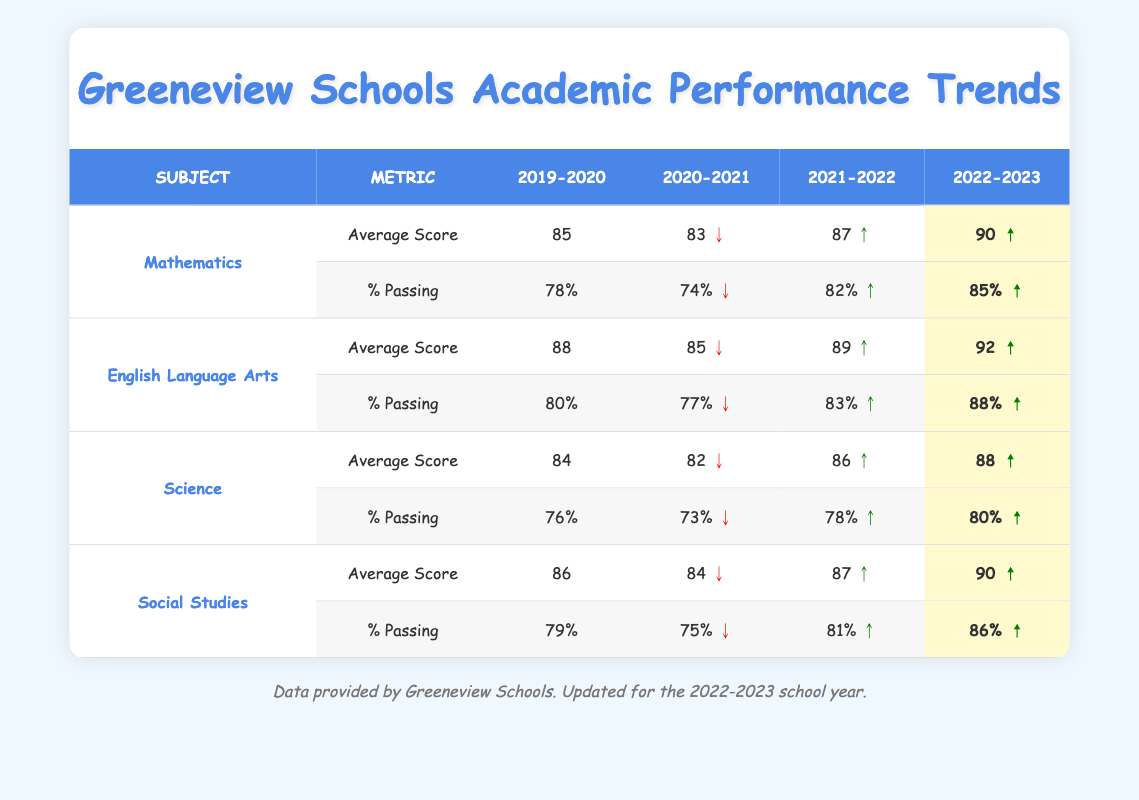What's the average score in Mathematics for the school year 2022-2023? The average score for Mathematics in 2022-2023 is directly provided in the table, which is 90.
Answer: 90 What was the percentage of students passing in English Language Arts for the school year 2020-2021? The percentage of students passing in English Language Arts for 2020-2021 is shown in the table as 77%.
Answer: 77% Which subject had the highest average score in the 2021-2022 school year? By comparing the average scores of all subjects for the year 2021-2022, Mathematics has an average score of 87, whereas other subjects have lower scores (English Language Arts 89, Science 86, and Social Studies 87), making English Language Arts the highest.
Answer: English Language Arts What is the trend for the percentage of students passing in Social Studies from 2019-2020 to 2022-2023? The percentage of students passing in Social Studies went from 79% to 86%, indicating an upward trend. We can also observe that the percentage improved each year.
Answer: Upward In which year did Science have the lowest average score? The table shows that Science had an average score of 82 in the year 2020-2021, which is the lowest compared to other years.
Answer: 2020-2021 What was the change in average scores for Mathematics from 2019-2020 to 2022-2023? The average score for Mathematics in 2019-2020 was 85 and increased to 90 in 2022-2023. The change can be calculated as 90 - 85 = 5.
Answer: Increase of 5 Was there a decline in the percentage of students passing in English Language Arts from 2019-2020 to 2020-2021? Checking the values, the percentage of students passing dropped from 80% in 2019-2020 to 77% in 2020-2021, which confirms there was a decline.
Answer: Yes Which subject improved the most in average score from 2020-2021 to 2022-2023? To find this, we compare the average scores: Mathematics (from 83 to 90) is an increase of 7, English Language Arts (85 to 92) is 7, Science (82 to 88) is 6, and Social Studies (84 to 90) is 6. Mathematics and English Language Arts both improved the most by 7 points.
Answer: Mathematics and English Language Arts What is the average percentage of students passing across all subjects in 2022-2023? To calculate this, add the percentage of students passing for all subjects in 2022-2023: Mathematics (85%) + English Language Arts (88%) + Science (80%) + Social Studies (86%) = 339%. Then divide by the number of subjects (4), giving an average of 339/4 = 84.75%.
Answer: 84.75% Was there a consistent increase in average scores across all subjects from 2019-2020 to 2022-2023? By analyzing the data, all subjects show an increase from 2019-2020 to 2022-2023: Mathematics (85 to 90), English Language Arts (88 to 92), Science (84 to 88), and Social Studies (86 to 90); thus confirming a consistent increase in average scores in all subjects.
Answer: Yes 